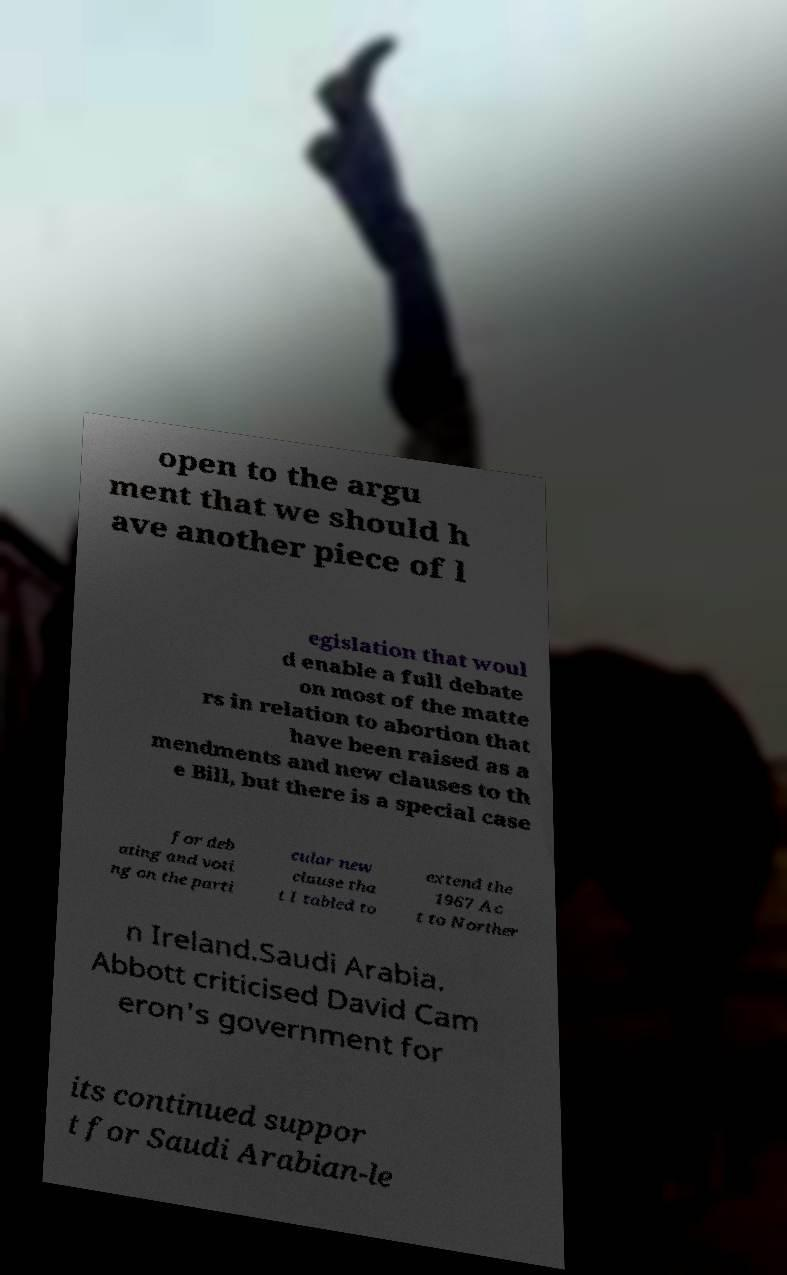Could you extract and type out the text from this image? open to the argu ment that we should h ave another piece of l egislation that woul d enable a full debate on most of the matte rs in relation to abortion that have been raised as a mendments and new clauses to th e Bill, but there is a special case for deb ating and voti ng on the parti cular new clause tha t I tabled to extend the 1967 Ac t to Norther n Ireland.Saudi Arabia. Abbott criticised David Cam eron's government for its continued suppor t for Saudi Arabian-le 